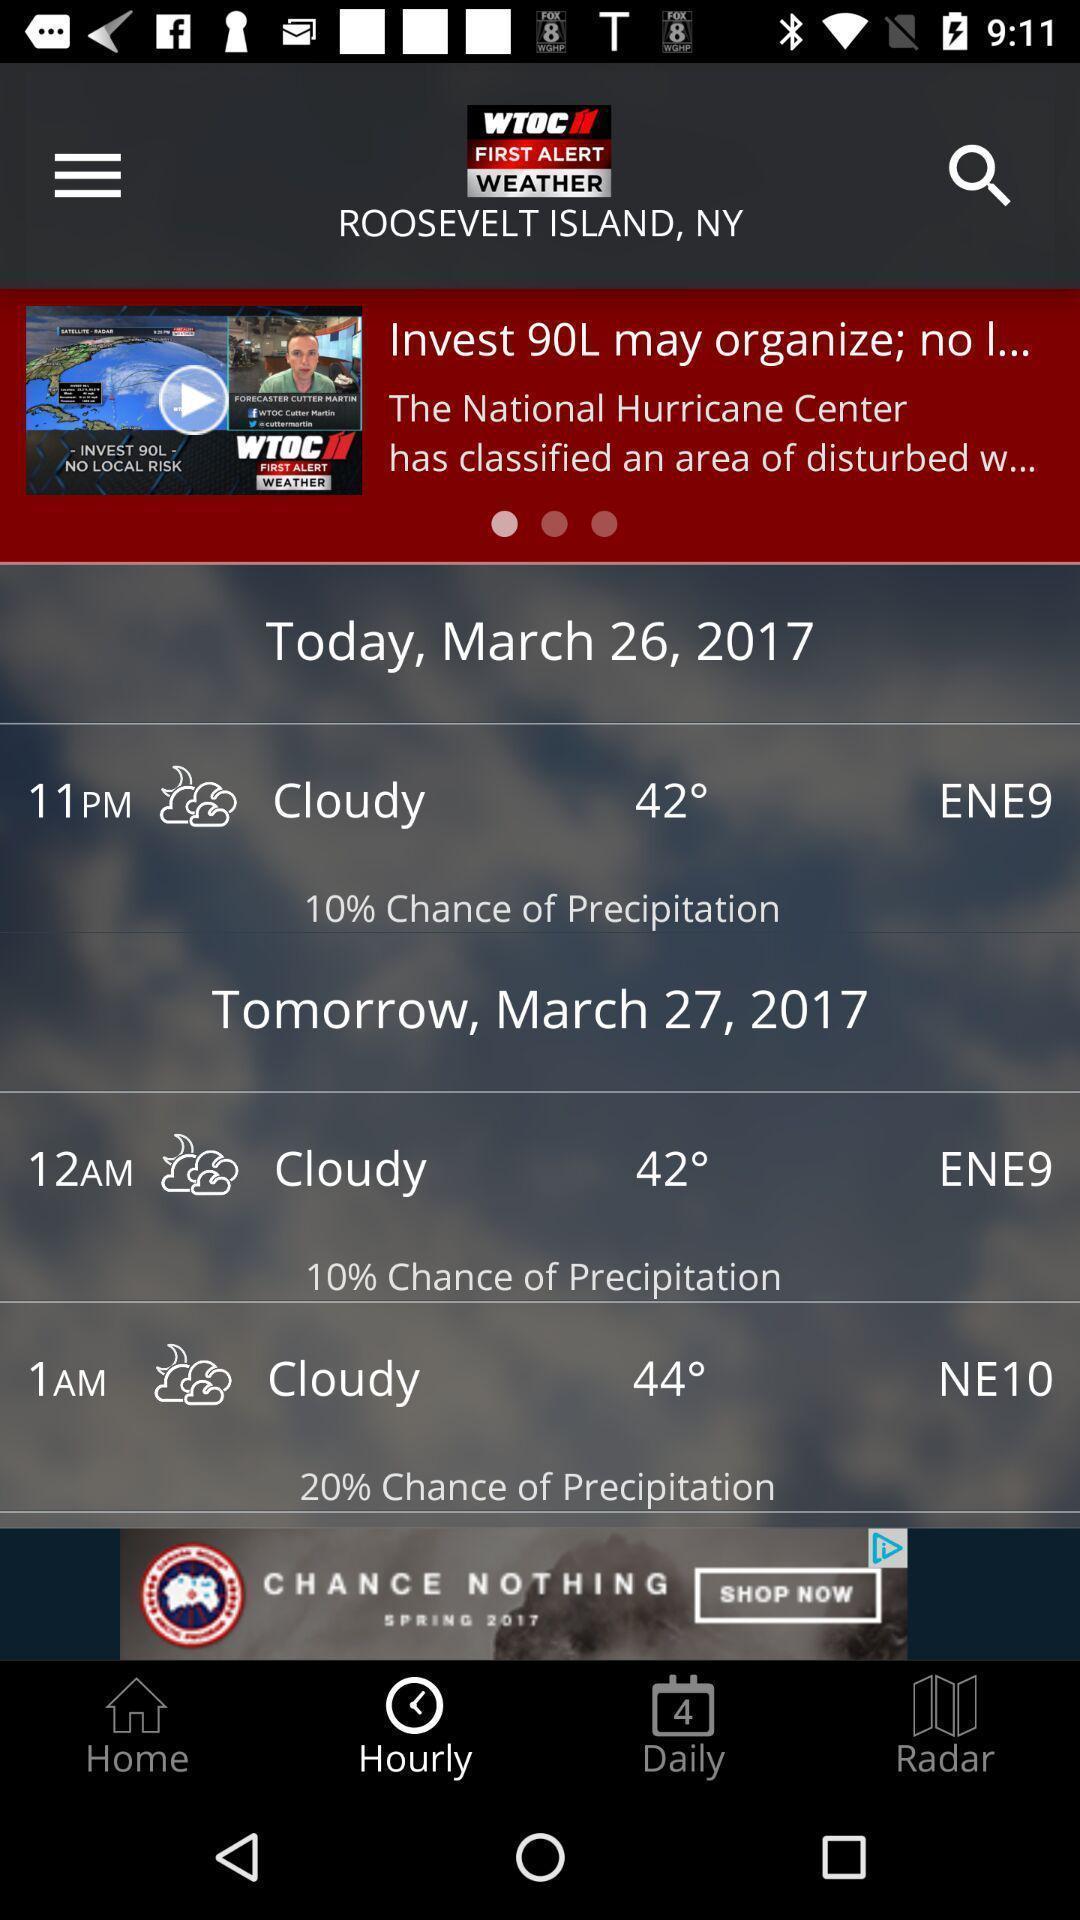Describe the key features of this screenshot. Page showing the weather conditions. 